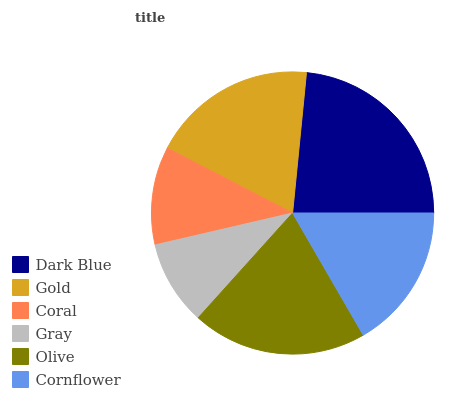Is Gray the minimum?
Answer yes or no. Yes. Is Dark Blue the maximum?
Answer yes or no. Yes. Is Gold the minimum?
Answer yes or no. No. Is Gold the maximum?
Answer yes or no. No. Is Dark Blue greater than Gold?
Answer yes or no. Yes. Is Gold less than Dark Blue?
Answer yes or no. Yes. Is Gold greater than Dark Blue?
Answer yes or no. No. Is Dark Blue less than Gold?
Answer yes or no. No. Is Gold the high median?
Answer yes or no. Yes. Is Cornflower the low median?
Answer yes or no. Yes. Is Cornflower the high median?
Answer yes or no. No. Is Gray the low median?
Answer yes or no. No. 